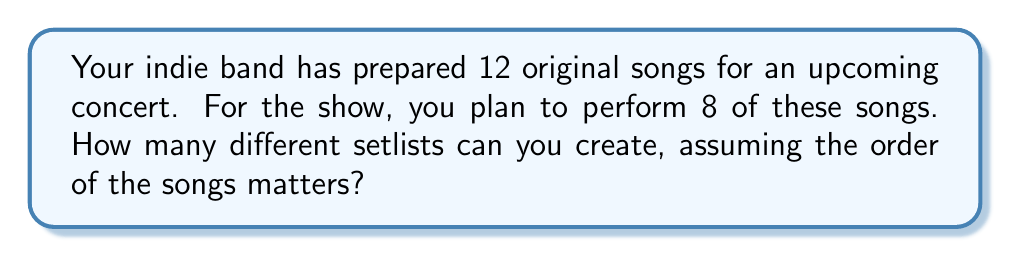Can you solve this math problem? Let's approach this step-by-step:

1) This is a permutation problem because the order of the songs matters in a setlist.

2) We are selecting 8 songs out of 12, and the order is important.

3) The formula for permutations is:

   $$P(n,r) = \frac{n!}{(n-r)!}$$

   Where $n$ is the total number of items to choose from, and $r$ is the number of items being chosen.

4) In this case, $n = 12$ (total songs) and $r = 8$ (songs in the setlist).

5) Plugging these numbers into the formula:

   $$P(12,8) = \frac{12!}{(12-8)!} = \frac{12!}{4!}$$

6) Expanding this:
   
   $$\frac{12 * 11 * 10 * 9 * 8 * 7 * 6 * 5 * 4!}{4!}$$

7) The $4!$ cancels out in the numerator and denominator:

   $$12 * 11 * 10 * 9 * 8 * 7 * 6 * 5 = 19,958,400$$

Therefore, there are 19,958,400 different possible setlists.
Answer: 19,958,400 